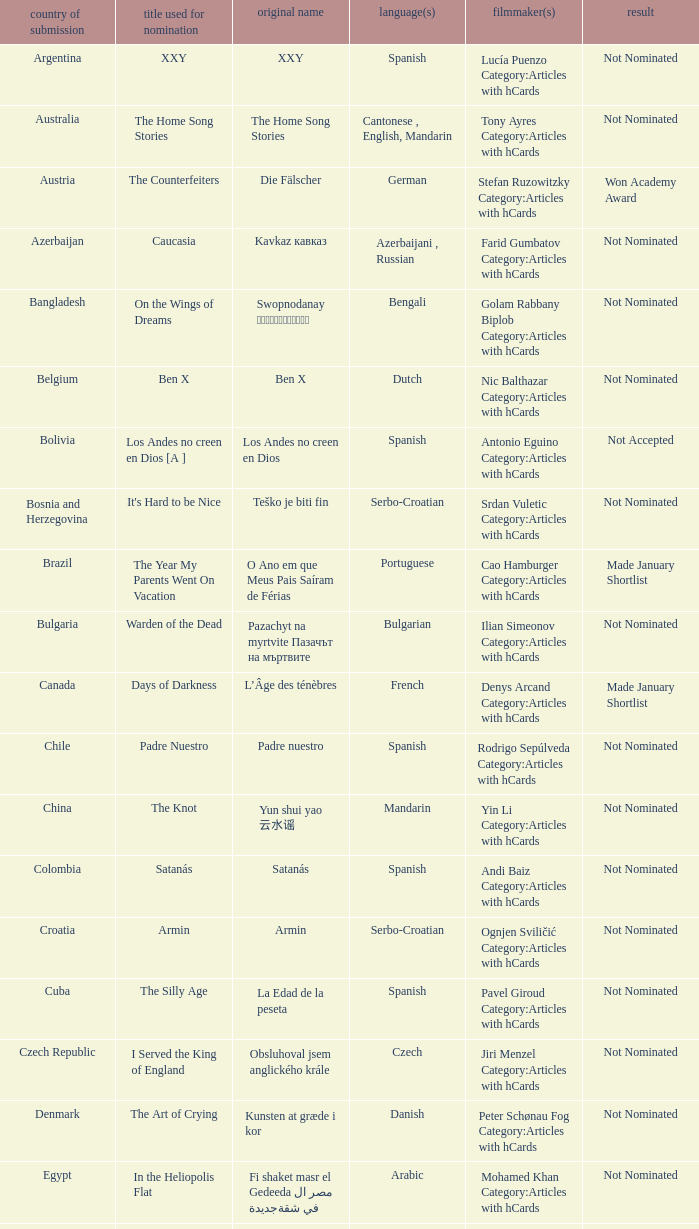What was the title of the movie from lebanon? Caramel. 